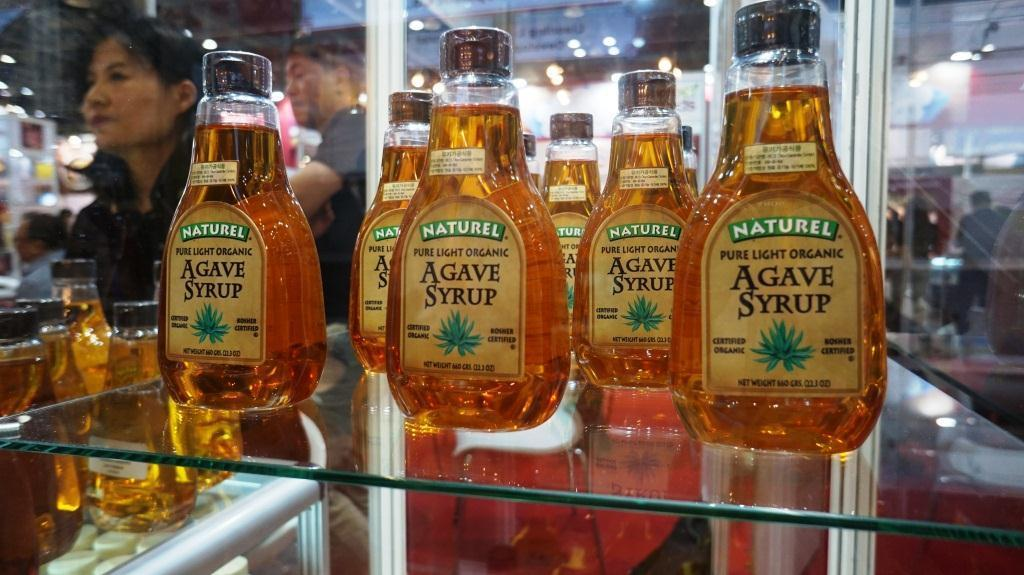<image>
Present a compact description of the photo's key features. Several bottles of Agave Syrup are displayed on a glass shelf. 